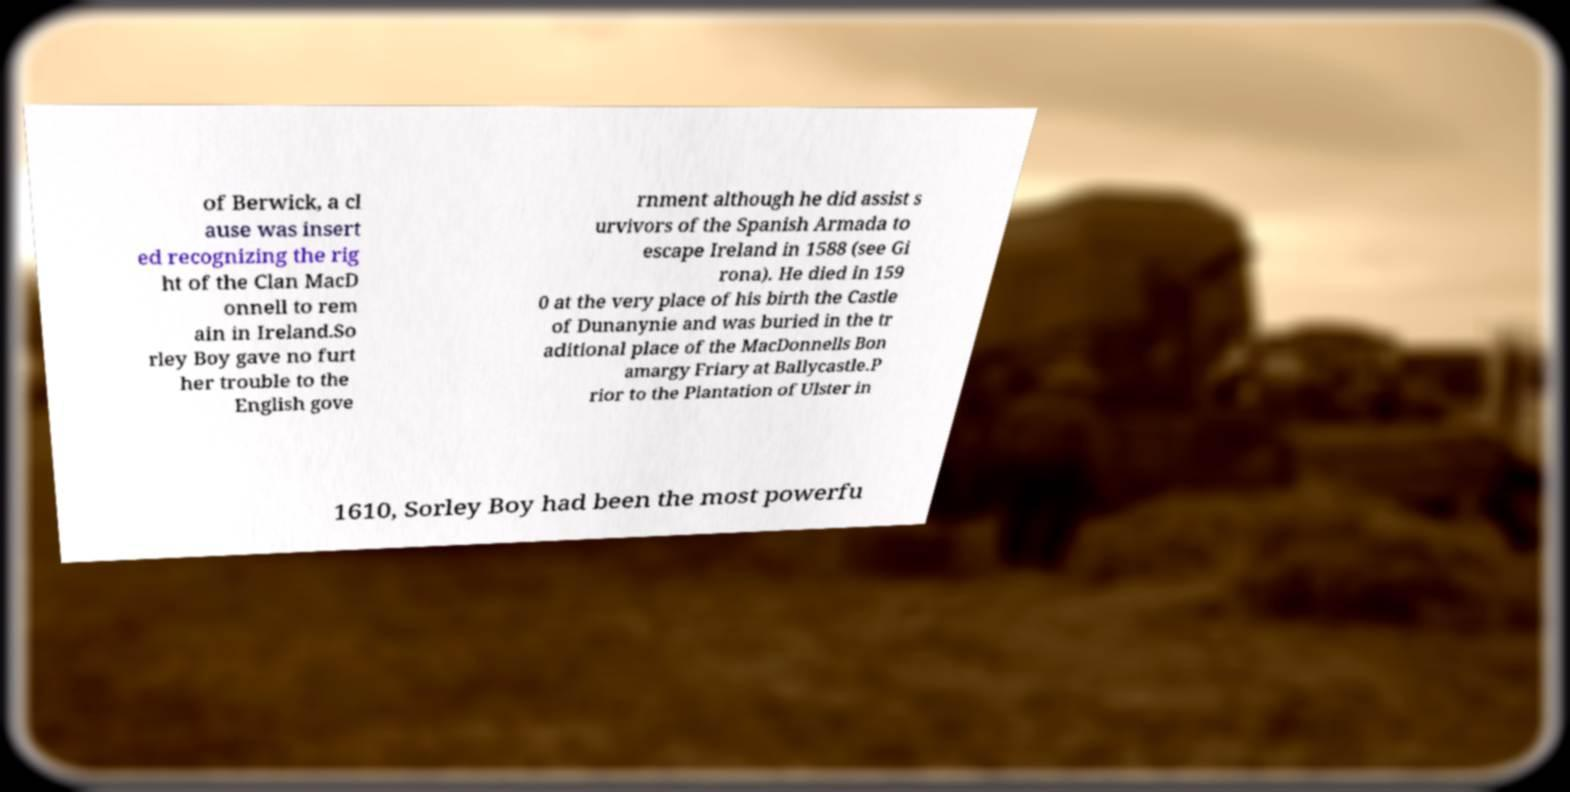Can you accurately transcribe the text from the provided image for me? of Berwick, a cl ause was insert ed recognizing the rig ht of the Clan MacD onnell to rem ain in Ireland.So rley Boy gave no furt her trouble to the English gove rnment although he did assist s urvivors of the Spanish Armada to escape Ireland in 1588 (see Gi rona). He died in 159 0 at the very place of his birth the Castle of Dunanynie and was buried in the tr aditional place of the MacDonnells Bon amargy Friary at Ballycastle.P rior to the Plantation of Ulster in 1610, Sorley Boy had been the most powerfu 